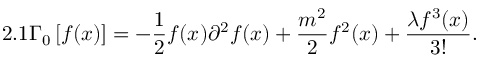Convert formula to latex. <formula><loc_0><loc_0><loc_500><loc_500>2 . 1 \Gamma _ { 0 } \left [ f ( x ) \right ] = - \frac { 1 } { 2 } f ( x ) \partial ^ { 2 } f ( x ) + \frac { m ^ { 2 } } { 2 } f ^ { 2 } ( x ) + \frac { \lambda f ^ { 3 } ( x ) } { 3 ! } .</formula> 